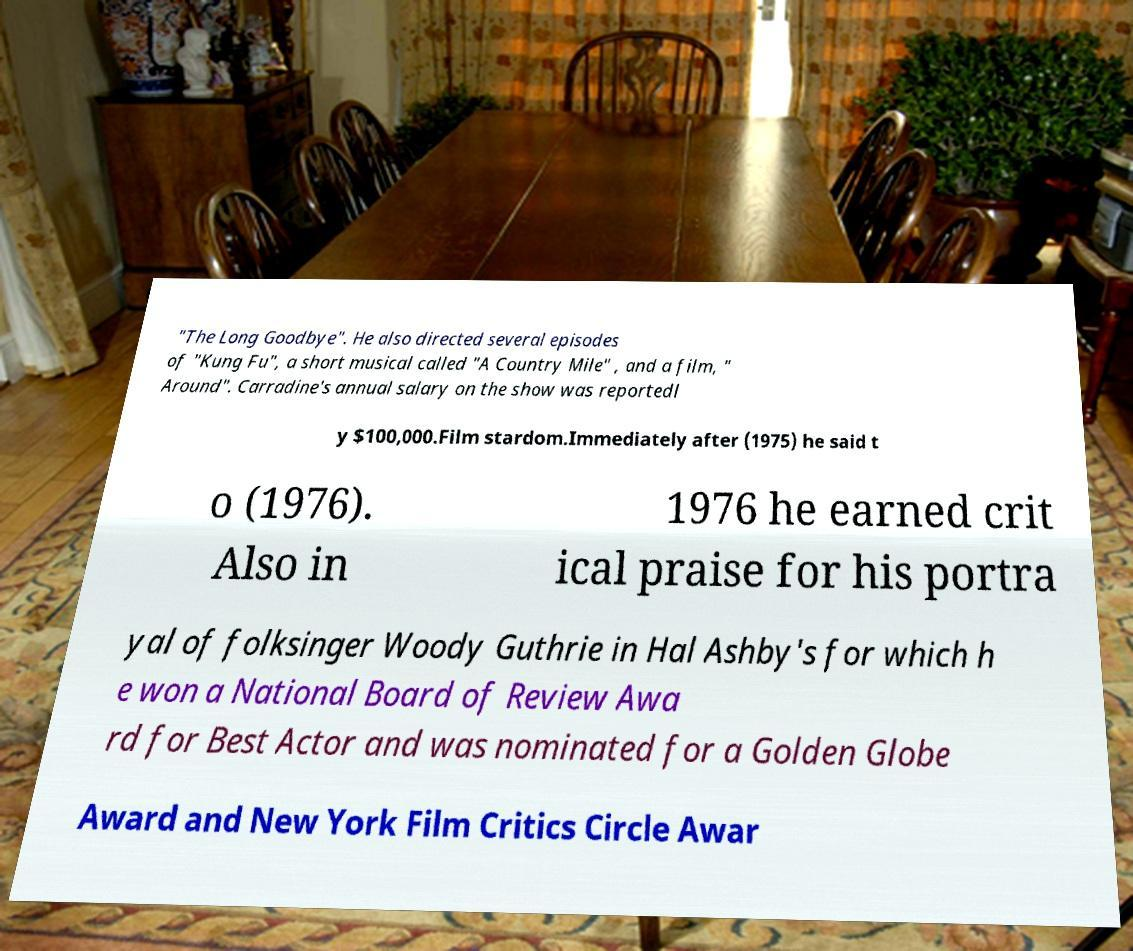What messages or text are displayed in this image? I need them in a readable, typed format. "The Long Goodbye". He also directed several episodes of "Kung Fu", a short musical called "A Country Mile" , and a film, " Around". Carradine's annual salary on the show was reportedl y $100,000.Film stardom.Immediately after (1975) he said t o (1976). Also in 1976 he earned crit ical praise for his portra yal of folksinger Woody Guthrie in Hal Ashby's for which h e won a National Board of Review Awa rd for Best Actor and was nominated for a Golden Globe Award and New York Film Critics Circle Awar 